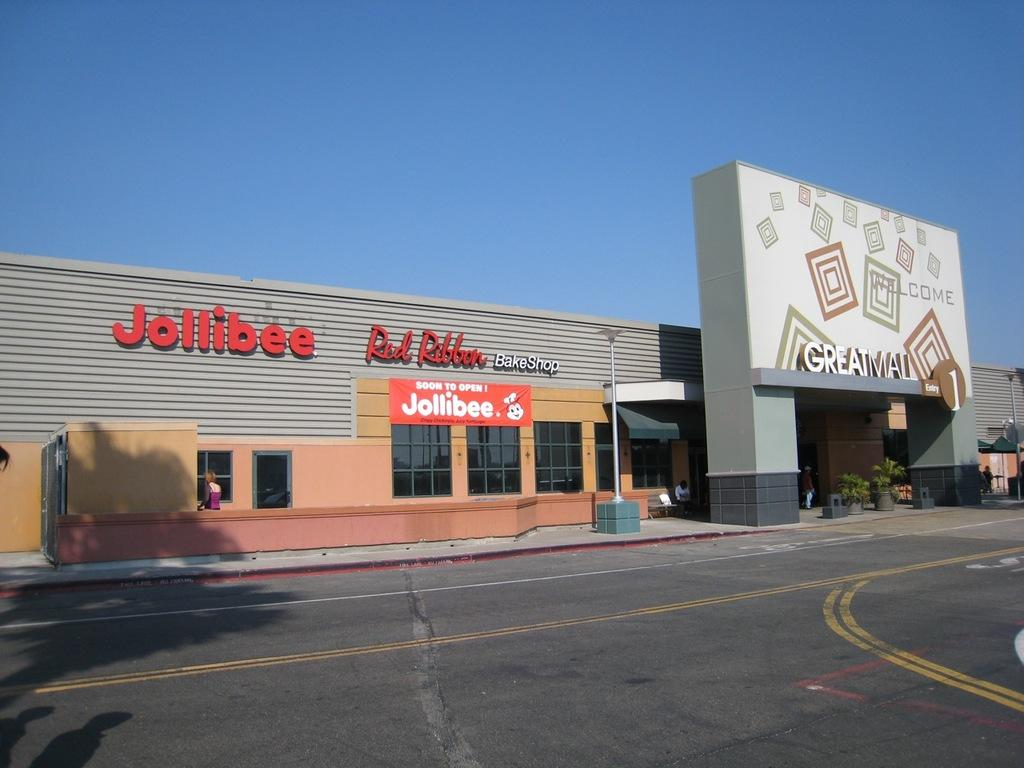What type of establishment is located in the middle of the image? There is a store in the middle of the image. What can be seen running through the image? There is a road visible in the image. What is visible at the top of the image? The sky is visible at the top of the image. How many fans are visible in the image? There are no fans present in the image. What type of tree can be seen in the image? There are no trees present in the image. 